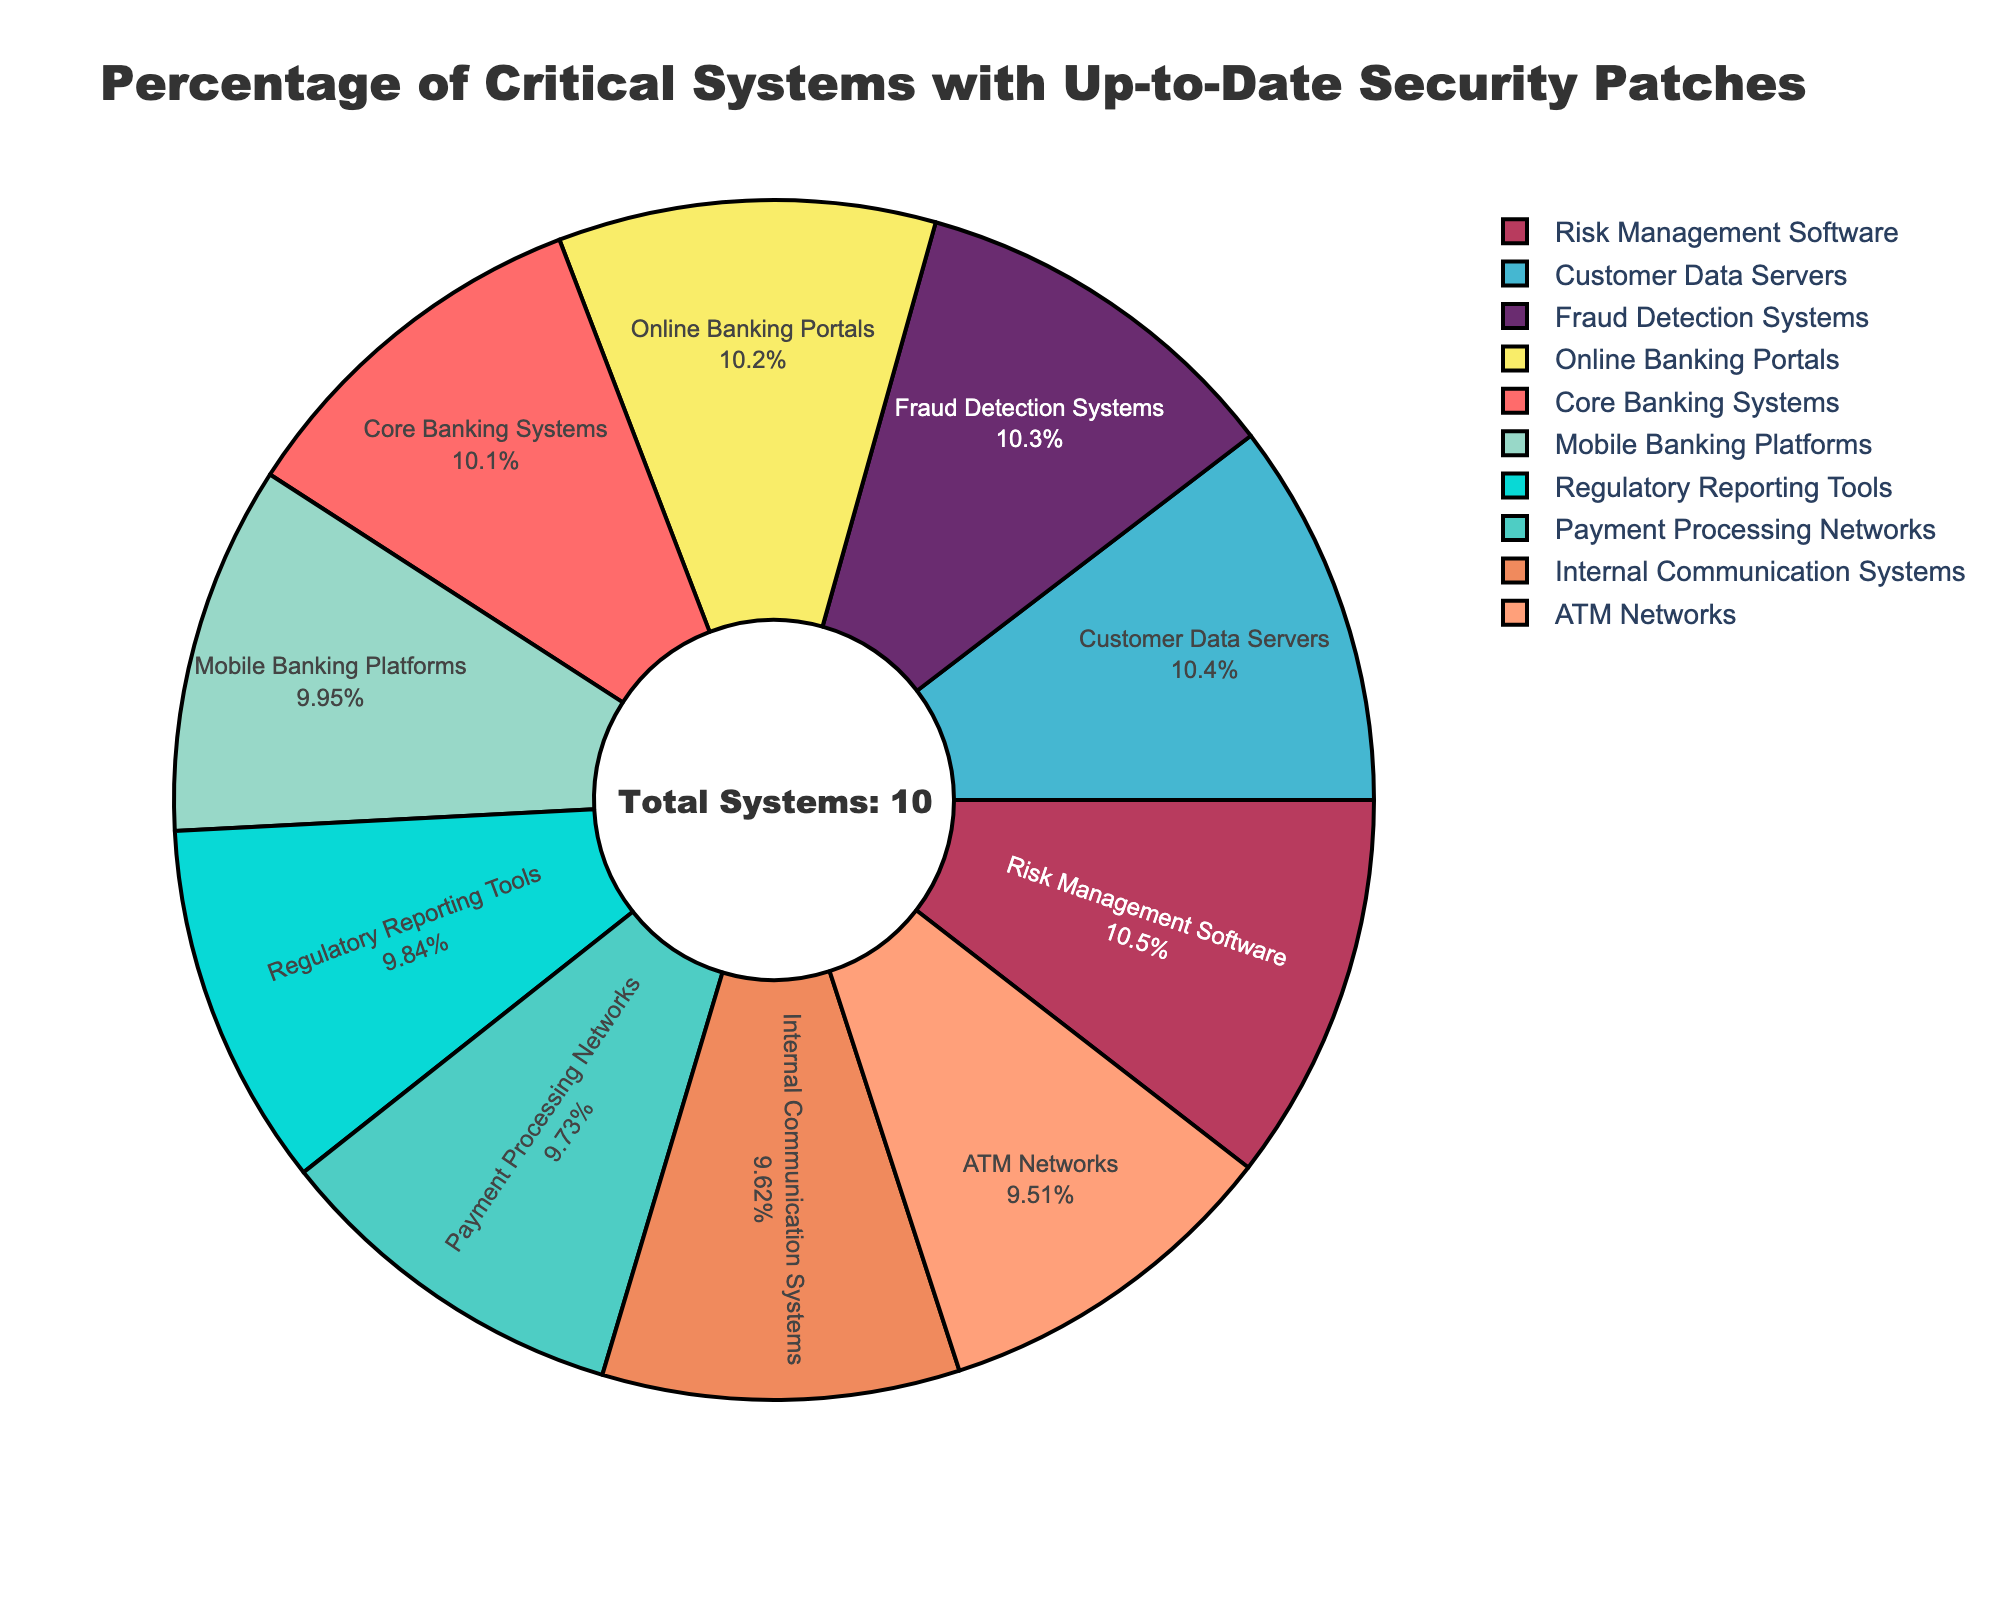What's the system type with the highest percentage of up-to-date patches? By looking at the pie chart, identify the segment with the highest percentage value, which corresponds to the system type with the highest up-to-date patches percentage.
Answer: Risk Management Software What percentage of ATM Networks have up-to-date security patches? Locate the segment labeled "ATM Networks" in the pie chart and look at the percentage value associated with it.
Answer: 87% Which system type has a higher percentage of up-to-date patches: Internal Communication Systems or Core Banking Systems? Identify and compare the percentage values for both Internal Communication Systems (88%) and Core Banking Systems (92%) from the pie chart.
Answer: Core Banking Systems What's the average percentage of up-to-date patches for Payment Processing Networks and Regulatory Reporting Tools? Identify the percentages for Payment Processing Networks (89%) and Regulatory Reporting Tools (90%), then calculate the average: (89 + 90) / 2 = 89.5
Answer: 89.5 How many percentage points difference is there between Online Banking Portals and ATM Networks? Identify the percentages for Online Banking Portals (93%) and ATM Networks (87%), then calculate the difference: 93 - 87 = 6
Answer: 6 Which three system types have the lowest percentage of up-to-date patches? Identify the three segments with the lowest percentages in the pie chart: ATM Networks (87%), Internal Communication Systems (88%), and Payment Processing Networks (89%).
Answer: ATM Networks, Internal Communication Systems, Payment Processing Networks What's the combined percentage of up-to-date patches for Customer Data Servers and Fraud Detection Systems? Identify the percentages for Customer Data Servers (95%) and Fraud Detection Systems (94%), then sum them up: 95 + 94 = 189
Answer: 189 Between Payment Processing Networks and Mobile Banking Platforms, which type is closer in percentage to Online Banking Portals? Identify the percentages for Payment Processing Networks (89%), Mobile Banking Platforms (91%), and Online Banking Portals (93%). Calculate the differences: 93 -89 = 4 for Payment Processing Networks and 93 - 91 = 2 for Mobile Banking Platforms.
Answer: Mobile Banking Platforms By how many percentage points does Risk Management Software exceed the average percentage of all systems' up-to-date patches? First, calculate the average percentage of all systems by summing all percentages and dividing by the number of systems, then subtract this average from the Risk Management Software percentage (96%). Average = (92 + 89 + 95 + 87 + 91 + 93 + 88 + 96 + 94 + 90) / 10 = 91.5; Difference: 96 - 91.5 = 4.5
Answer: 4.5 What visual feature indicates the ring style of the pie chart? Observe the chart's design and note that there is a hole in the center, contributing to a donut or ring style.
Answer: Hole 